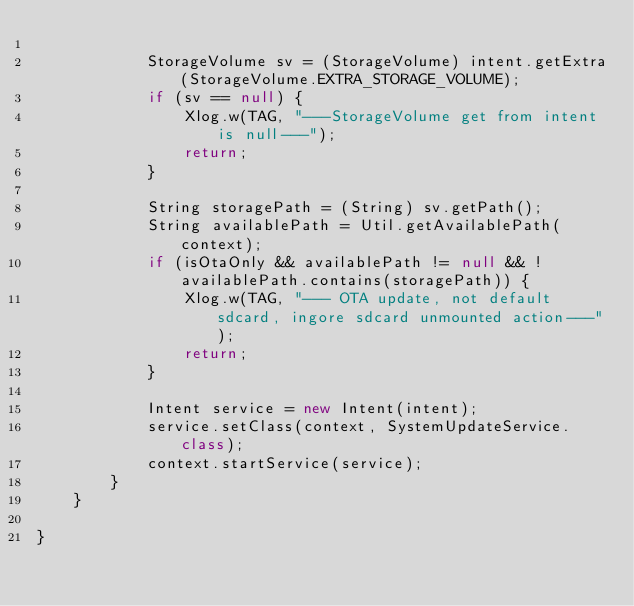Convert code to text. <code><loc_0><loc_0><loc_500><loc_500><_Java_>
            StorageVolume sv = (StorageVolume) intent.getExtra(StorageVolume.EXTRA_STORAGE_VOLUME);
            if (sv == null) {
                Xlog.w(TAG, "---StorageVolume get from intent is null---");
                return;
            }

            String storagePath = (String) sv.getPath();
            String availablePath = Util.getAvailablePath(context);
            if (isOtaOnly && availablePath != null && !availablePath.contains(storagePath)) {
                Xlog.w(TAG, "--- OTA update, not default sdcard, ingore sdcard unmounted action---");
                return;
            }

            Intent service = new Intent(intent);
            service.setClass(context, SystemUpdateService.class);
            context.startService(service);
        }
    }

}</code> 